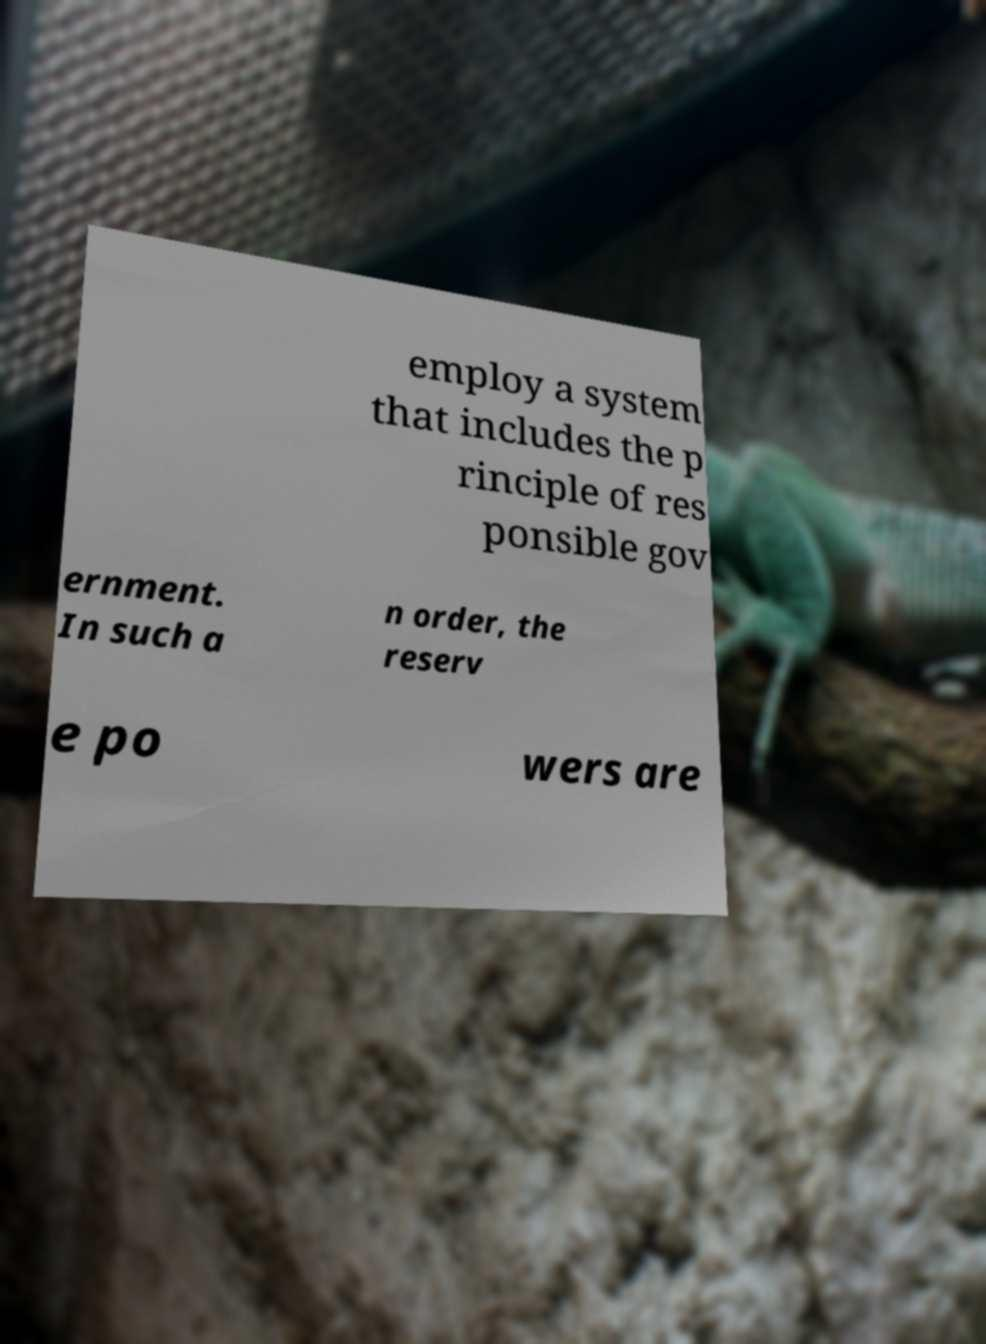There's text embedded in this image that I need extracted. Can you transcribe it verbatim? employ a system that includes the p rinciple of res ponsible gov ernment. In such a n order, the reserv e po wers are 